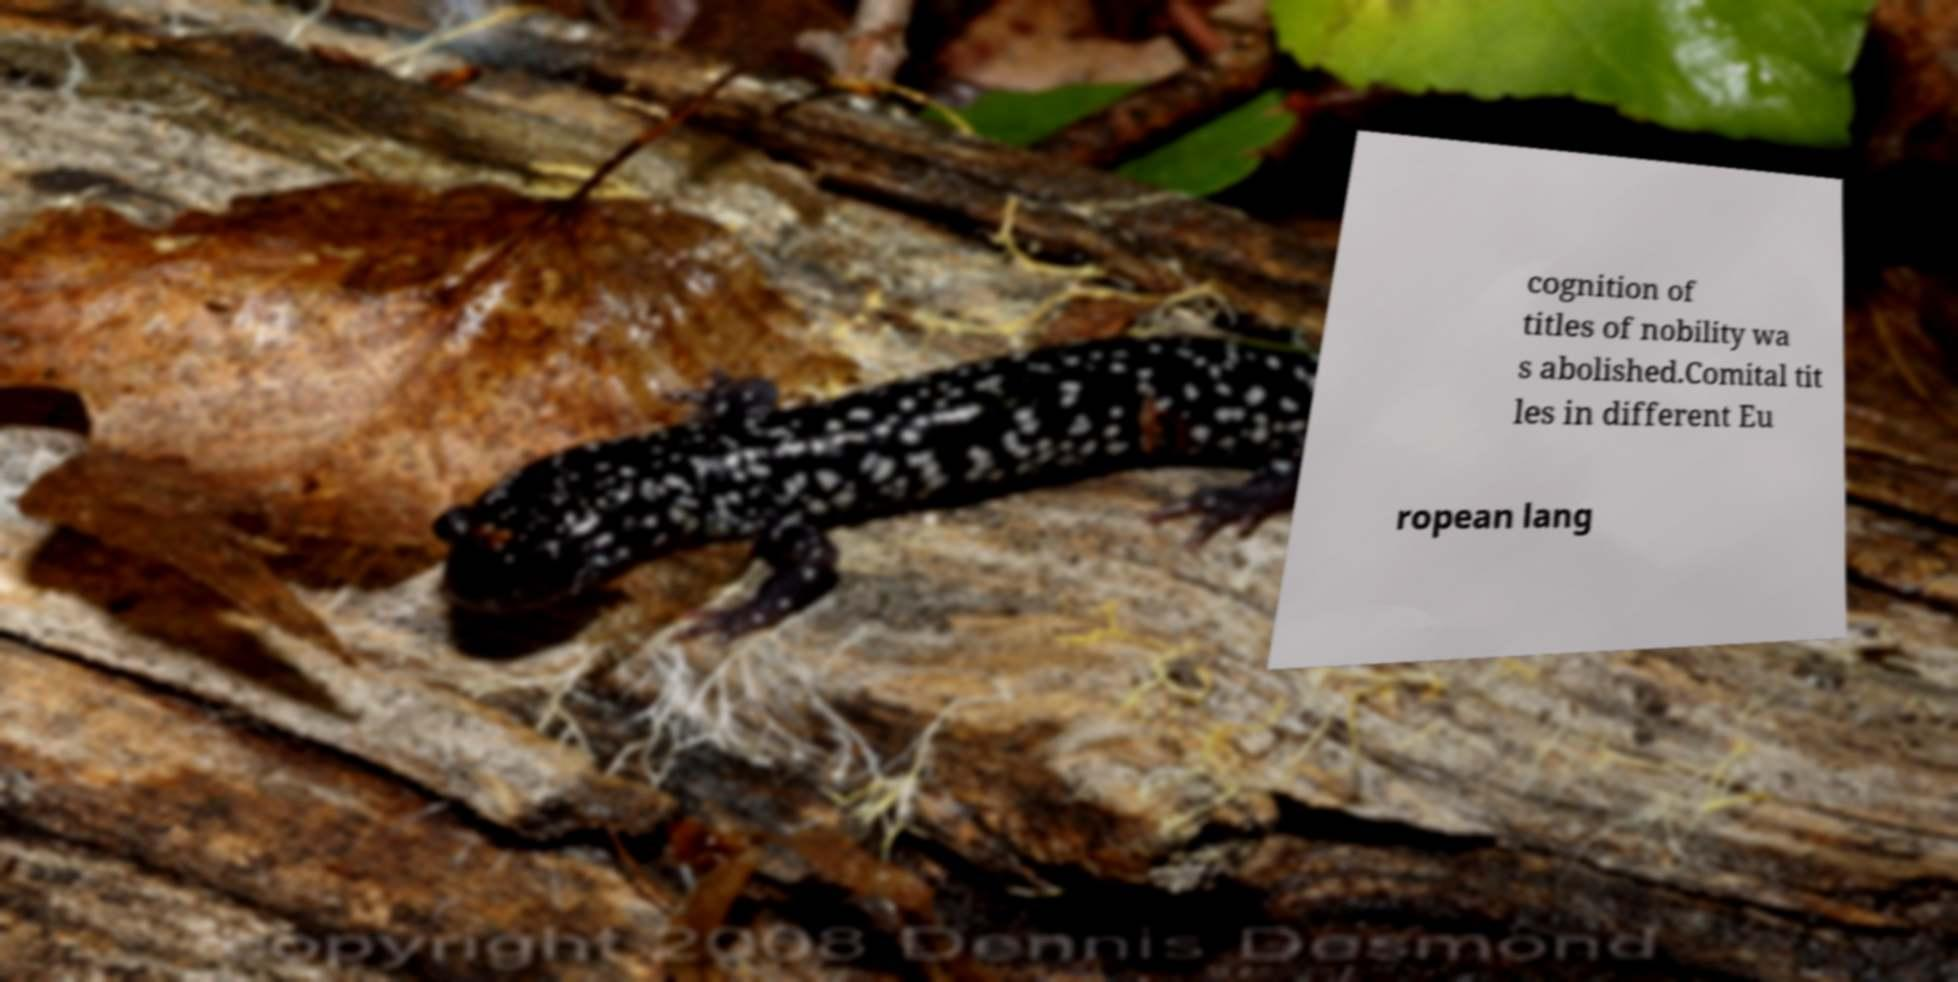Can you accurately transcribe the text from the provided image for me? cognition of titles of nobility wa s abolished.Comital tit les in different Eu ropean lang 